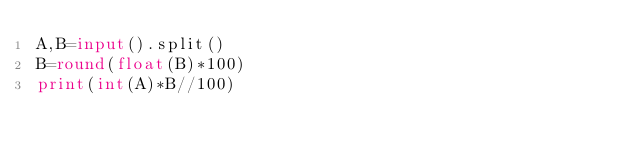<code> <loc_0><loc_0><loc_500><loc_500><_Python_>A,B=input().split()
B=round(float(B)*100)
print(int(A)*B//100)</code> 